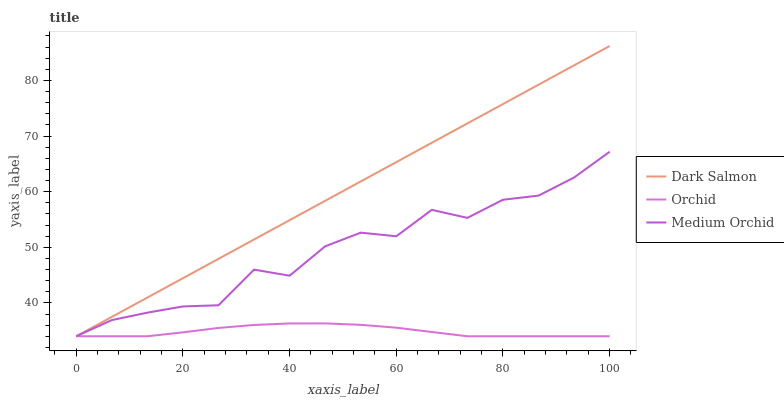Does Dark Salmon have the minimum area under the curve?
Answer yes or no. No. Does Orchid have the maximum area under the curve?
Answer yes or no. No. Is Orchid the smoothest?
Answer yes or no. No. Is Orchid the roughest?
Answer yes or no. No. Does Orchid have the highest value?
Answer yes or no. No. 